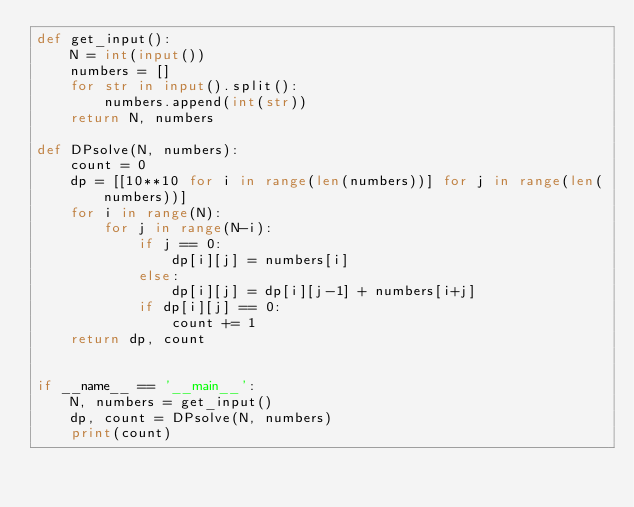<code> <loc_0><loc_0><loc_500><loc_500><_Python_>def get_input():
    N = int(input())
    numbers = []
    for str in input().split():
        numbers.append(int(str))
    return N, numbers

def DPsolve(N, numbers):
    count = 0
    dp = [[10**10 for i in range(len(numbers))] for j in range(len(numbers))]
    for i in range(N):
        for j in range(N-i):
            if j == 0:
                dp[i][j] = numbers[i]
            else:
                dp[i][j] = dp[i][j-1] + numbers[i+j]
            if dp[i][j] == 0:
                count += 1
    return dp, count


if __name__ == '__main__':
    N, numbers = get_input()
    dp, count = DPsolve(N, numbers)
    print(count)</code> 